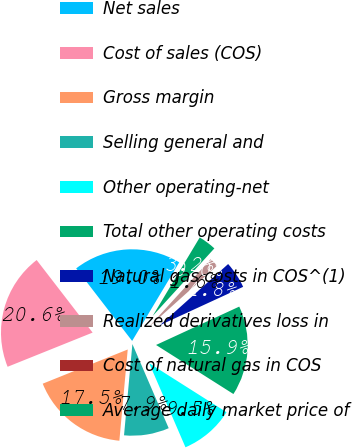Convert chart to OTSL. <chart><loc_0><loc_0><loc_500><loc_500><pie_chart><fcel>Net sales<fcel>Cost of sales (COS)<fcel>Gross margin<fcel>Selling general and<fcel>Other operating-net<fcel>Total other operating costs<fcel>Natural gas costs in COS^(1)<fcel>Realized derivatives loss in<fcel>Cost of natural gas in COS<fcel>Average daily market price of<nl><fcel>19.05%<fcel>20.63%<fcel>17.46%<fcel>7.94%<fcel>9.52%<fcel>15.87%<fcel>4.76%<fcel>1.59%<fcel>0.0%<fcel>3.18%<nl></chart> 